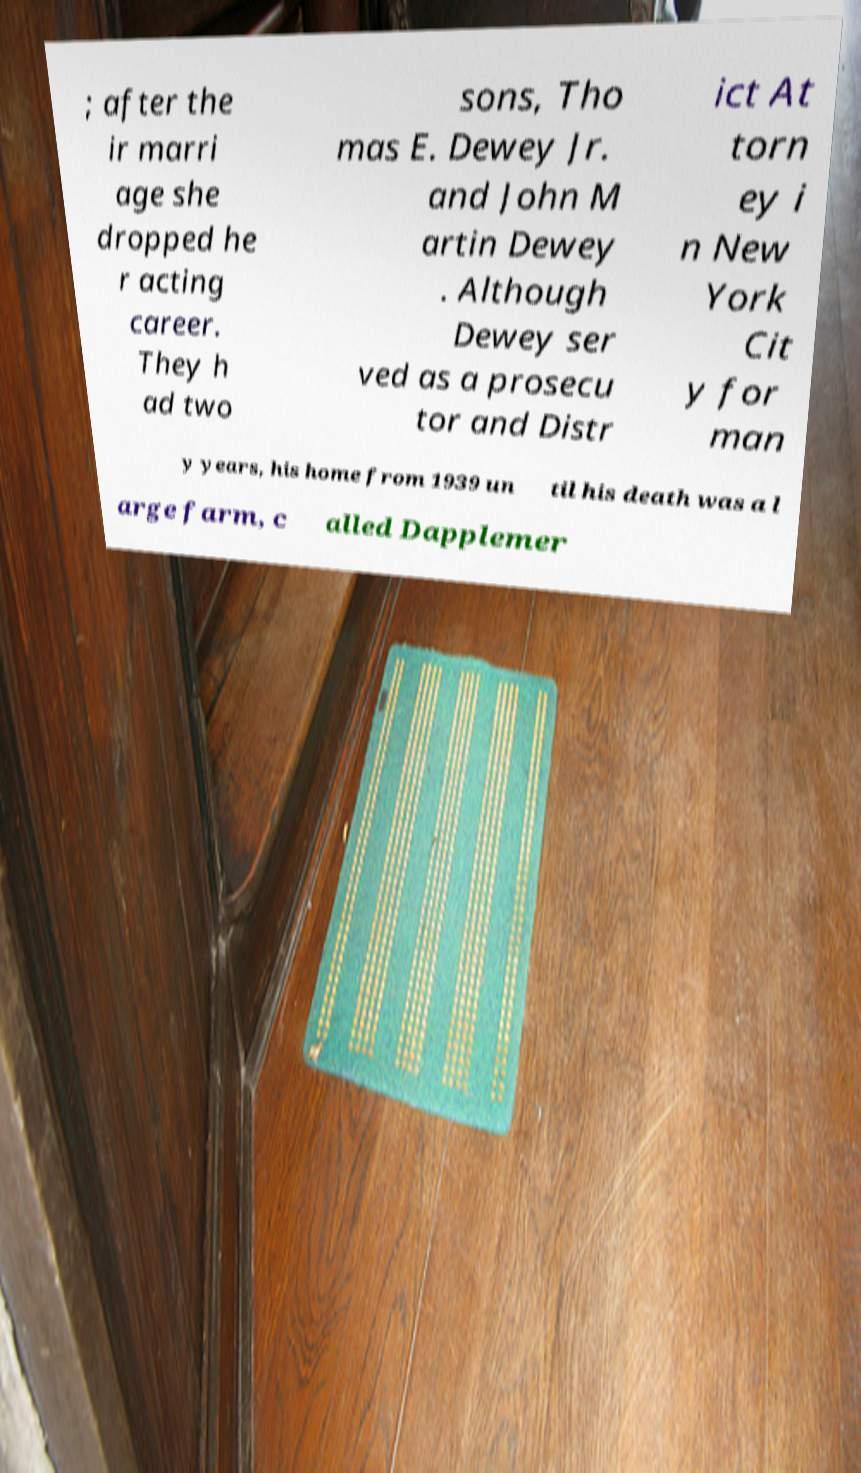Can you read and provide the text displayed in the image?This photo seems to have some interesting text. Can you extract and type it out for me? ; after the ir marri age she dropped he r acting career. They h ad two sons, Tho mas E. Dewey Jr. and John M artin Dewey . Although Dewey ser ved as a prosecu tor and Distr ict At torn ey i n New York Cit y for man y years, his home from 1939 un til his death was a l arge farm, c alled Dapplemer 